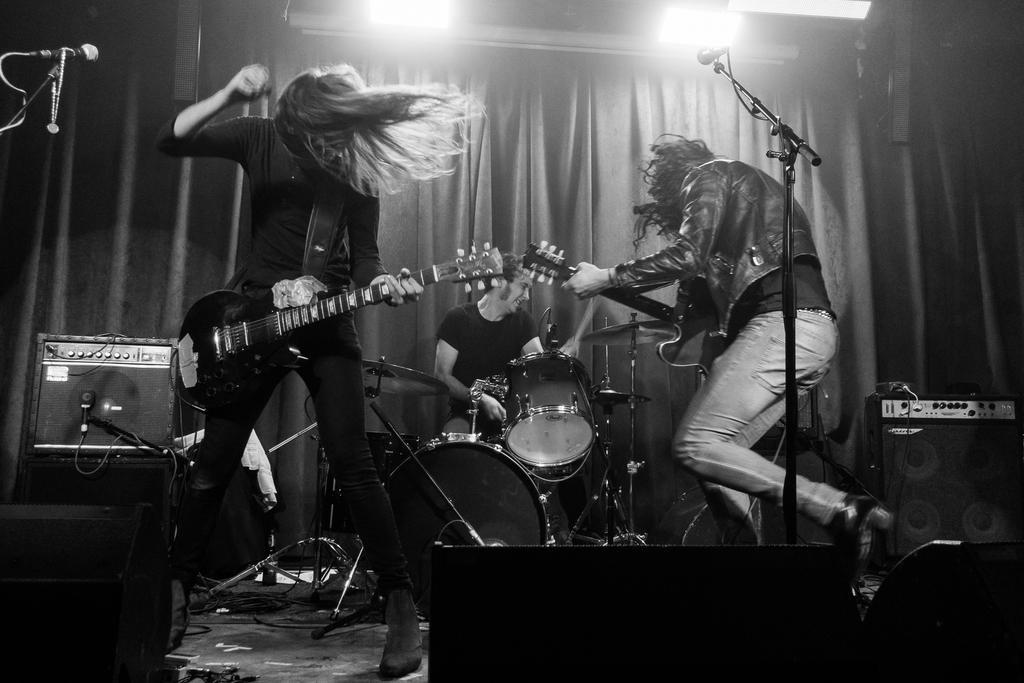Could you give a brief overview of what you see in this image? This picture is taken inside a room. there are three people in the room. The person at the left corner of the image is holding a guitar and dancing. The person at the right corner of the image is playing the guitar as well as dancing. The man in the center is playing drums. On the floor there are speakers, drums and drum stands. In front of them there are microphones and their stands. In the background there is curtain. In the top of the image there are lights. 